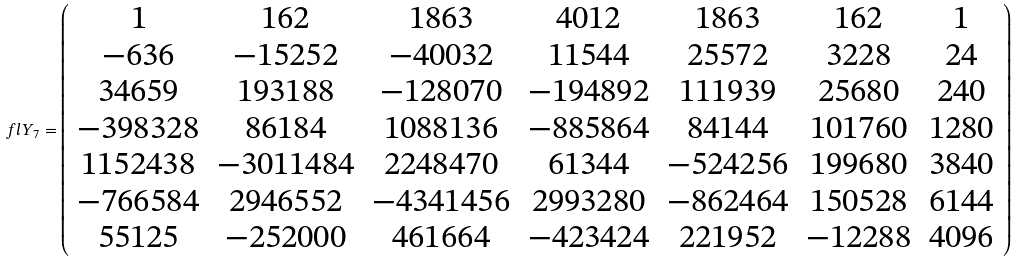<formula> <loc_0><loc_0><loc_500><loc_500>\ f l Y _ { 7 } = \left ( \begin{array} { c c c c c c c } 1 & 1 6 2 & 1 8 6 3 & 4 0 1 2 & 1 8 6 3 & 1 6 2 & 1 \\ - 6 3 6 & - 1 5 2 5 2 & - 4 0 0 3 2 & 1 1 5 4 4 & 2 5 5 7 2 & 3 2 2 8 & 2 4 \\ 3 4 6 5 9 & 1 9 3 1 8 8 & - 1 2 8 0 7 0 & - 1 9 4 8 9 2 & 1 1 1 9 3 9 & 2 5 6 8 0 & 2 4 0 \\ - 3 9 8 3 2 8 & 8 6 1 8 4 & 1 0 8 8 1 3 6 & - 8 8 5 8 6 4 & 8 4 1 4 4 & 1 0 1 7 6 0 & 1 2 8 0 \\ 1 1 5 2 4 3 8 & - 3 0 1 1 4 8 4 & 2 2 4 8 4 7 0 & 6 1 3 4 4 & - 5 2 4 2 5 6 & 1 9 9 6 8 0 & 3 8 4 0 \\ - 7 6 6 5 8 4 & 2 9 4 6 5 5 2 & - 4 3 4 1 4 5 6 & 2 9 9 3 2 8 0 & - 8 6 2 4 6 4 & 1 5 0 5 2 8 & 6 1 4 4 \\ 5 5 1 2 5 & - 2 5 2 0 0 0 & 4 6 1 6 6 4 & - 4 2 3 4 2 4 & 2 2 1 9 5 2 & - 1 2 2 8 8 & 4 0 9 6 \end{array} \right )</formula> 